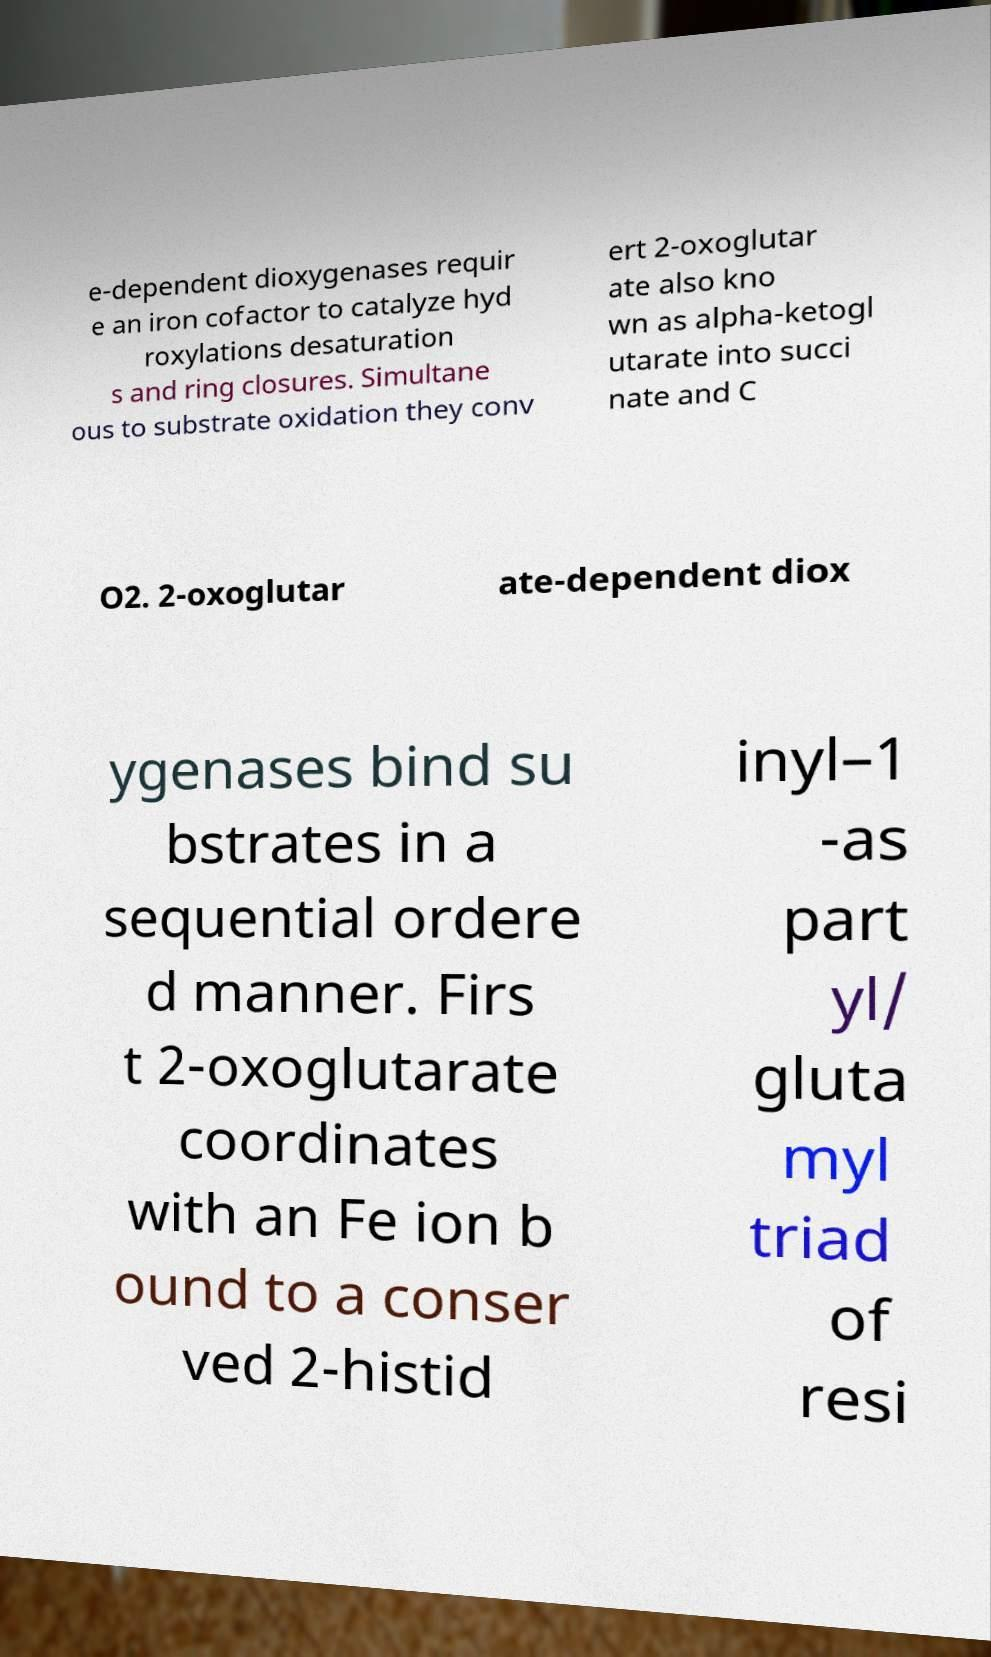For documentation purposes, I need the text within this image transcribed. Could you provide that? e-dependent dioxygenases requir e an iron cofactor to catalyze hyd roxylations desaturation s and ring closures. Simultane ous to substrate oxidation they conv ert 2-oxoglutar ate also kno wn as alpha-ketogl utarate into succi nate and C O2. 2-oxoglutar ate-dependent diox ygenases bind su bstrates in a sequential ordere d manner. Firs t 2-oxoglutarate coordinates with an Fe ion b ound to a conser ved 2-histid inyl–1 -as part yl/ gluta myl triad of resi 